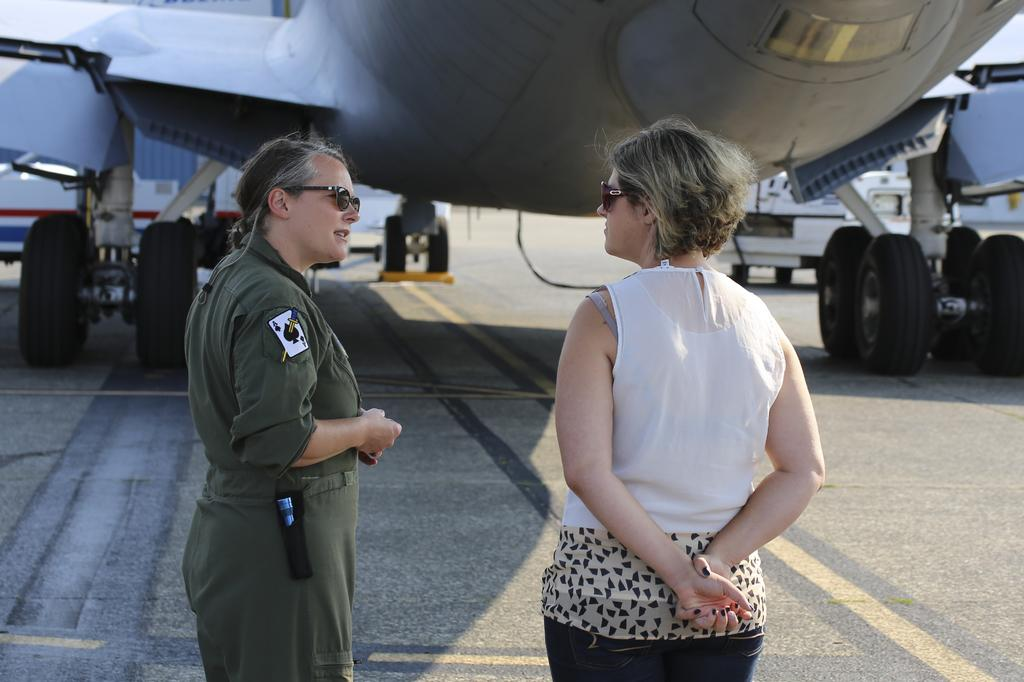How many people are standing on the road in the image? There are two persons standing on the road in the image. What else can be seen in the image besides the people on the road? There is an airplane and a vehicle in the image. What type of tray is being used for the distribution of the airplane in the image? There is no tray or distribution of the airplane in the image; it is simply a stationary object in the background. 